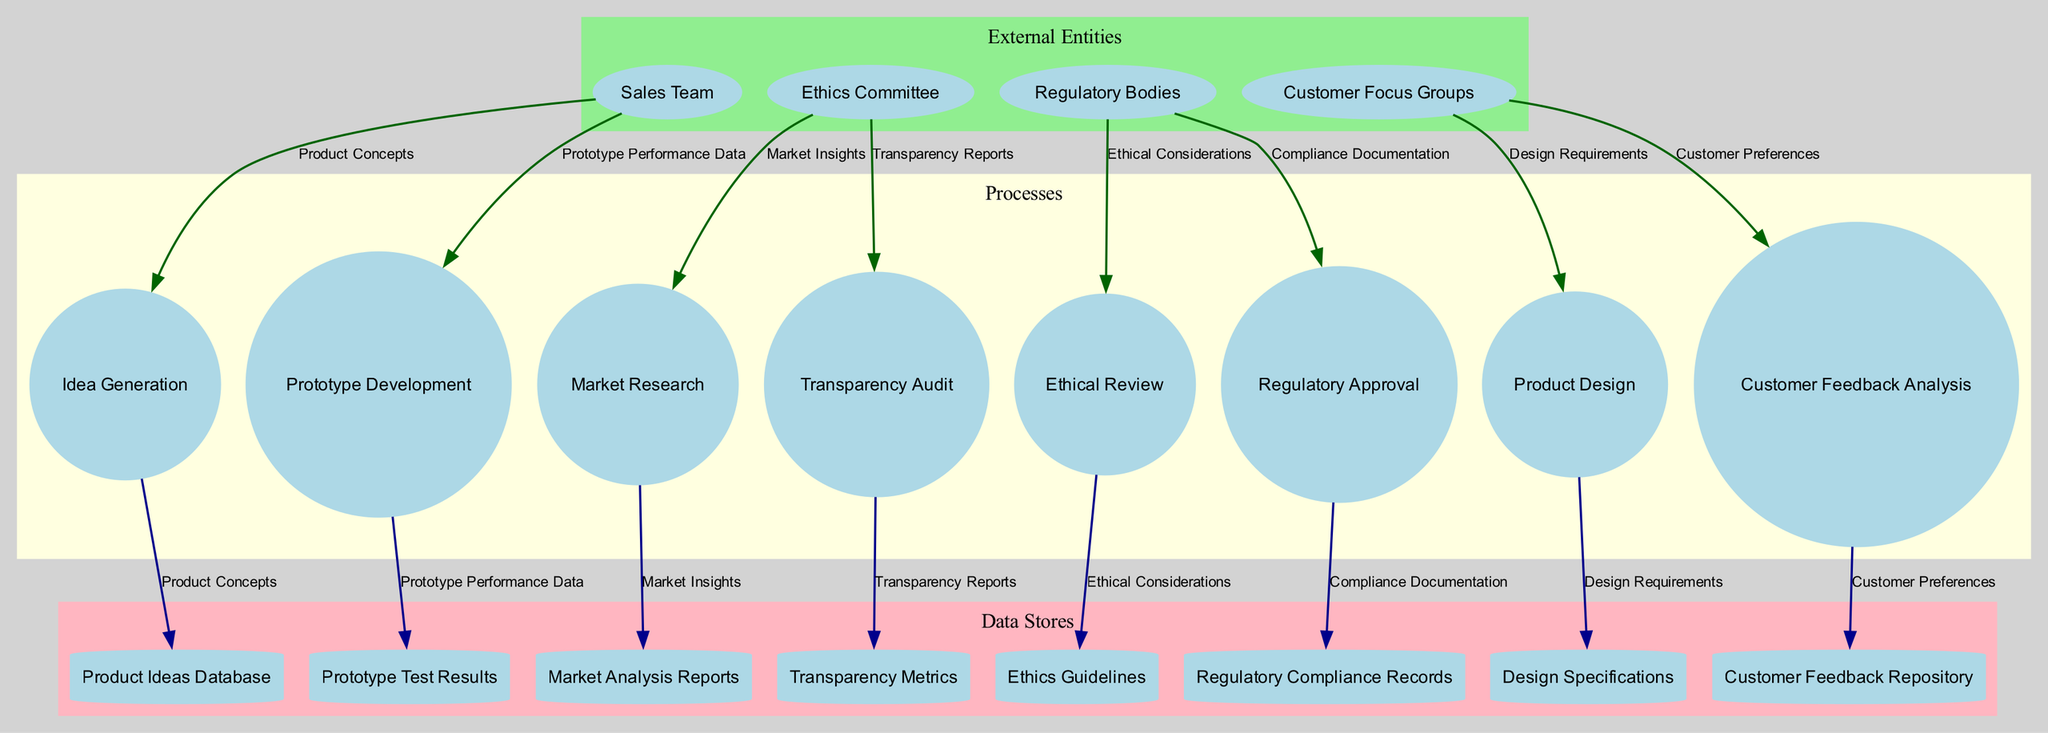What are the external entities involved in the process? The diagram identifies four external entities: Sales Team, Ethics Committee, Regulatory Bodies, and Customer Focus Groups. This information can be found in the section labeled "External Entities."
Answer: Sales Team, Ethics Committee, Regulatory Bodies, Customer Focus Groups How many processes are present in the diagram? The diagram lists a total of eight processes, shown in the "Processes" section of the diagram.
Answer: Eight Which data store holds customer feedback? The "Customer Feedback Repository" is specifically mentioned in the data stores, indicating it holds customer feedback.
Answer: Customer Feedback Repository What is the flow from the Ethics Committee to the Ethical Review? The flow labeled "Ethical Considerations" indicates that this data flows from the Ethics Committee to the Ethical Review process. This relationship can be traced through the connections in the diagram.
Answer: Ethical Considerations Which process leads to Regulatory Approval? The process that leads to "Regulatory Approval" comes after "Transparency Audit." This can be inferred from the arrangement of processes connected in the diagram.
Answer: Transparency Audit What type of diagram is being used? The diagram type displayed is a Data Flow Diagram, as indicated by the title and structure focusing on processes, data flows, external entities, and data stores.
Answer: Data Flow Diagram How many data stores are illustrated in the diagram? The diagram includes a total of eight data stores, presented in the "Data Stores" section of the diagram.
Answer: Eight Which flow provides insights to the Market Research process? "Market Insights" is the designated flow giving information to the "Market Research" process, as indicated in the arrows and labels of the diagram.
Answer: Market Insights Which external entity connects with Prototype Development? The "Sales Team" is the external entity that connects with the "Prototype Development" process through the flow labeled "Product Concepts." This is seen through the directed arrows in the diagram.
Answer: Sales Team 